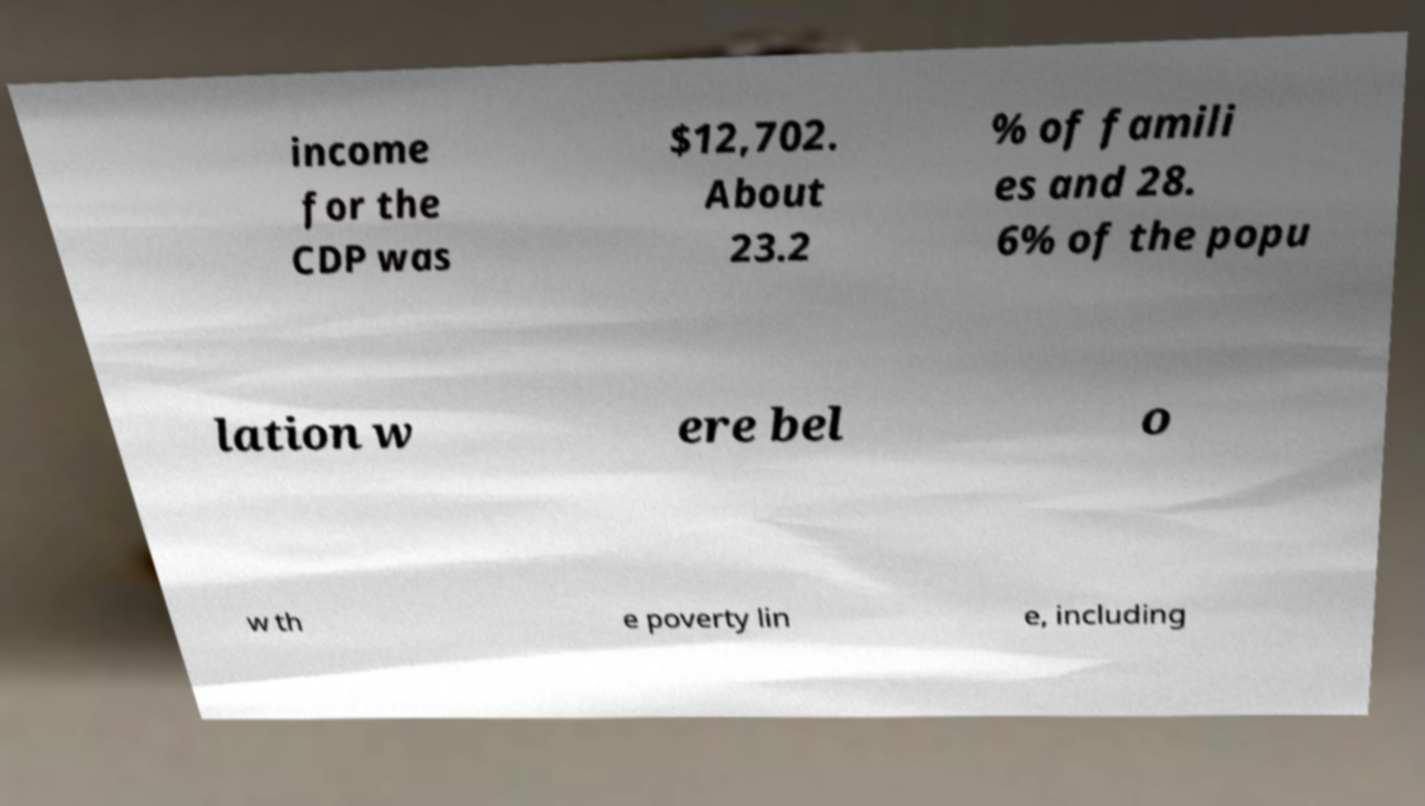For documentation purposes, I need the text within this image transcribed. Could you provide that? income for the CDP was $12,702. About 23.2 % of famili es and 28. 6% of the popu lation w ere bel o w th e poverty lin e, including 